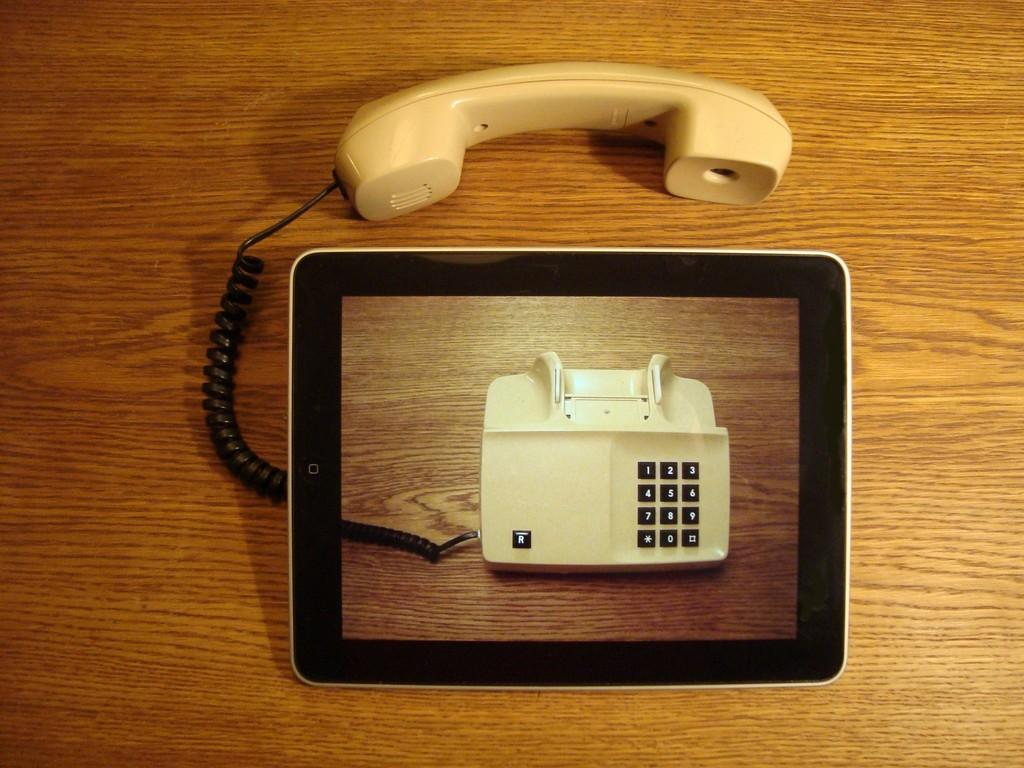What objects are in the middle of the image? There is a tab and a telephone in the middle of the image. Can you describe the tab in the image? The tab is a small, flat object that is likely used for opening or closing something. What is the other object in the middle of the image? There is a telephone in the image. What type of jam is being spread on the stocking in the image? There is no jam or stocking present in the image; it only features a tab and a telephone. 